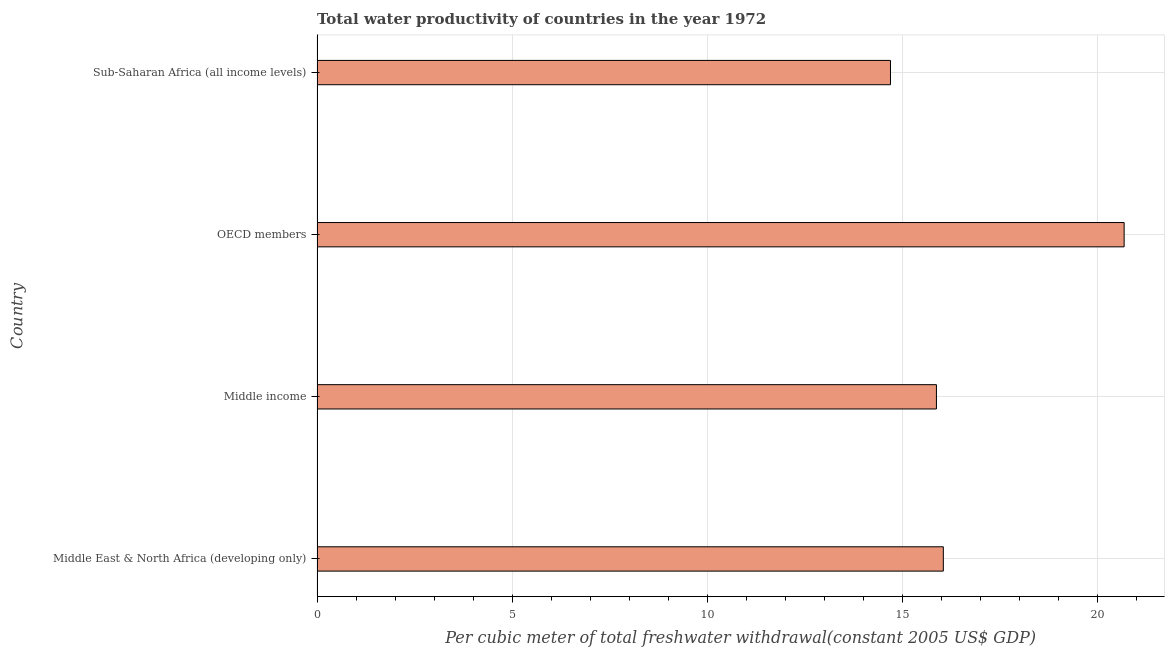Does the graph contain grids?
Keep it short and to the point. Yes. What is the title of the graph?
Ensure brevity in your answer.  Total water productivity of countries in the year 1972. What is the label or title of the X-axis?
Make the answer very short. Per cubic meter of total freshwater withdrawal(constant 2005 US$ GDP). What is the label or title of the Y-axis?
Give a very brief answer. Country. What is the total water productivity in Middle East & North Africa (developing only)?
Offer a terse response. 16.06. Across all countries, what is the maximum total water productivity?
Make the answer very short. 20.7. Across all countries, what is the minimum total water productivity?
Make the answer very short. 14.7. In which country was the total water productivity maximum?
Ensure brevity in your answer.  OECD members. In which country was the total water productivity minimum?
Ensure brevity in your answer.  Sub-Saharan Africa (all income levels). What is the sum of the total water productivity?
Make the answer very short. 67.34. What is the difference between the total water productivity in Middle East & North Africa (developing only) and Middle income?
Offer a very short reply. 0.18. What is the average total water productivity per country?
Your response must be concise. 16.84. What is the median total water productivity?
Your answer should be compact. 15.97. In how many countries, is the total water productivity greater than 10 US$?
Make the answer very short. 4. What is the ratio of the total water productivity in Middle income to that in OECD members?
Keep it short and to the point. 0.77. Is the difference between the total water productivity in OECD members and Sub-Saharan Africa (all income levels) greater than the difference between any two countries?
Your response must be concise. Yes. What is the difference between the highest and the second highest total water productivity?
Ensure brevity in your answer.  4.64. What is the difference between the highest and the lowest total water productivity?
Offer a very short reply. 5.99. What is the Per cubic meter of total freshwater withdrawal(constant 2005 US$ GDP) of Middle East & North Africa (developing only)?
Keep it short and to the point. 16.06. What is the Per cubic meter of total freshwater withdrawal(constant 2005 US$ GDP) of Middle income?
Ensure brevity in your answer.  15.88. What is the Per cubic meter of total freshwater withdrawal(constant 2005 US$ GDP) of OECD members?
Ensure brevity in your answer.  20.7. What is the Per cubic meter of total freshwater withdrawal(constant 2005 US$ GDP) in Sub-Saharan Africa (all income levels)?
Provide a succinct answer. 14.7. What is the difference between the Per cubic meter of total freshwater withdrawal(constant 2005 US$ GDP) in Middle East & North Africa (developing only) and Middle income?
Offer a very short reply. 0.18. What is the difference between the Per cubic meter of total freshwater withdrawal(constant 2005 US$ GDP) in Middle East & North Africa (developing only) and OECD members?
Give a very brief answer. -4.64. What is the difference between the Per cubic meter of total freshwater withdrawal(constant 2005 US$ GDP) in Middle East & North Africa (developing only) and Sub-Saharan Africa (all income levels)?
Provide a succinct answer. 1.35. What is the difference between the Per cubic meter of total freshwater withdrawal(constant 2005 US$ GDP) in Middle income and OECD members?
Give a very brief answer. -4.81. What is the difference between the Per cubic meter of total freshwater withdrawal(constant 2005 US$ GDP) in Middle income and Sub-Saharan Africa (all income levels)?
Keep it short and to the point. 1.18. What is the difference between the Per cubic meter of total freshwater withdrawal(constant 2005 US$ GDP) in OECD members and Sub-Saharan Africa (all income levels)?
Your answer should be very brief. 5.99. What is the ratio of the Per cubic meter of total freshwater withdrawal(constant 2005 US$ GDP) in Middle East & North Africa (developing only) to that in Middle income?
Offer a very short reply. 1.01. What is the ratio of the Per cubic meter of total freshwater withdrawal(constant 2005 US$ GDP) in Middle East & North Africa (developing only) to that in OECD members?
Provide a succinct answer. 0.78. What is the ratio of the Per cubic meter of total freshwater withdrawal(constant 2005 US$ GDP) in Middle East & North Africa (developing only) to that in Sub-Saharan Africa (all income levels)?
Provide a succinct answer. 1.09. What is the ratio of the Per cubic meter of total freshwater withdrawal(constant 2005 US$ GDP) in Middle income to that in OECD members?
Provide a succinct answer. 0.77. What is the ratio of the Per cubic meter of total freshwater withdrawal(constant 2005 US$ GDP) in OECD members to that in Sub-Saharan Africa (all income levels)?
Offer a terse response. 1.41. 